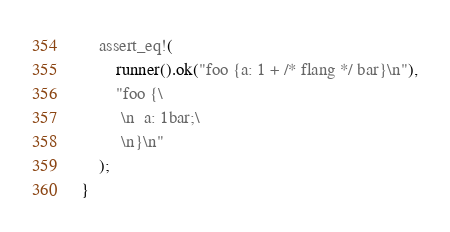<code> <loc_0><loc_0><loc_500><loc_500><_Rust_>    assert_eq!(
        runner().ok("foo {a: 1 + /* flang */ bar}\n"),
        "foo {\
         \n  a: 1bar;\
         \n}\n"
    );
}
</code> 